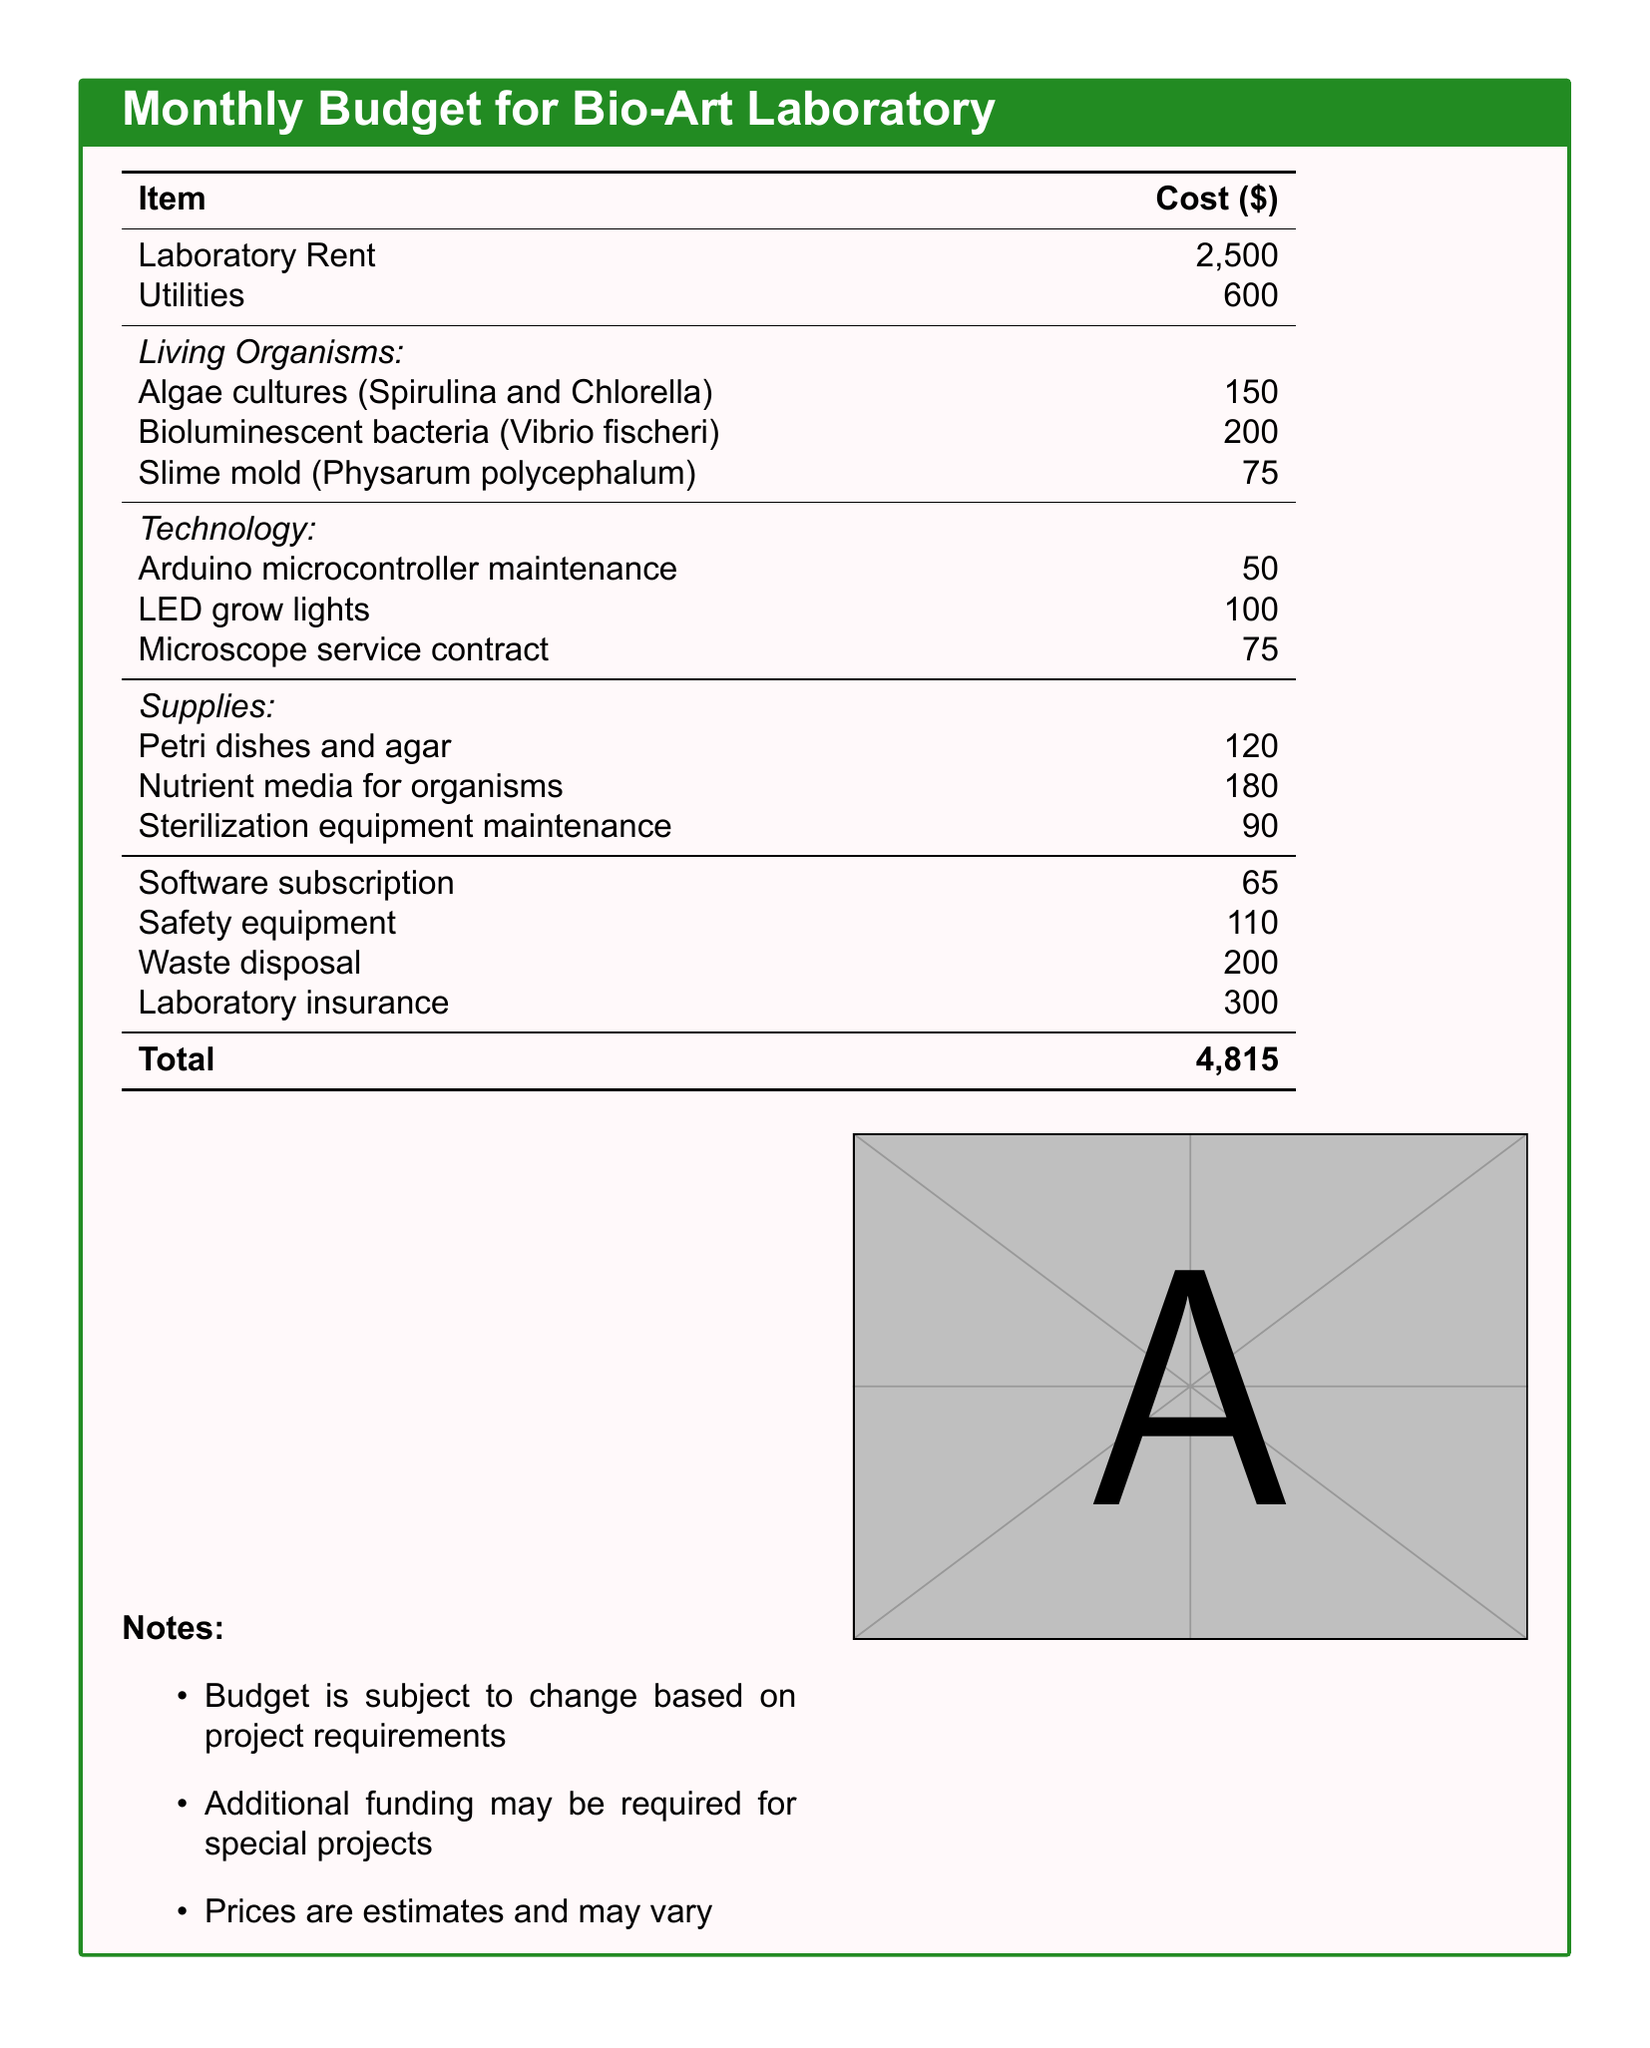What is the total cost of the budget? The total cost is listed at the bottom of the table, summing up all the individual costs.
Answer: 4,815 How much does the laboratory rent cost? The cost of laboratory rent is specifically stated in the budget table.
Answer: 2,500 What are the algae cultures mentioned in the document? The types of algae cultures included in the budget are stated under the living organisms section.
Answer: Spirulina and Chlorella What is the cost for bioluminescent bacteria? The cost for bioluminescent bacteria is explicitly mentioned in the budget.
Answer: 200 How much is allocated for nutrient media for organisms? The budget specifies the cost for nutrient media under the supplies section.
Answer: 180 What is the maintenance cost for the Arduino microcontroller? This cost is listed in the technology section of the budget.
Answer: 50 How many items are listed under living organisms? The budget lists different living organisms, and counting them gives the total.
Answer: 3 What is included in the supplies cost? The supplies section contains different items along with their costs.
Answer: Petri dishes and agar, nutrient media for organisms, sterilization equipment maintenance What is the purpose of the notes section? The notes section provides additional context regarding the budget and its variability.
Answer: Additional funding may be required for special projects 